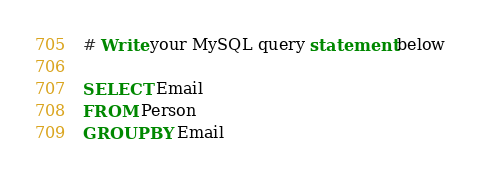Convert code to text. <code><loc_0><loc_0><loc_500><loc_500><_SQL_># Write your MySQL query statement below

SELECT Email
FROM Person
GROUP BY Email</code> 